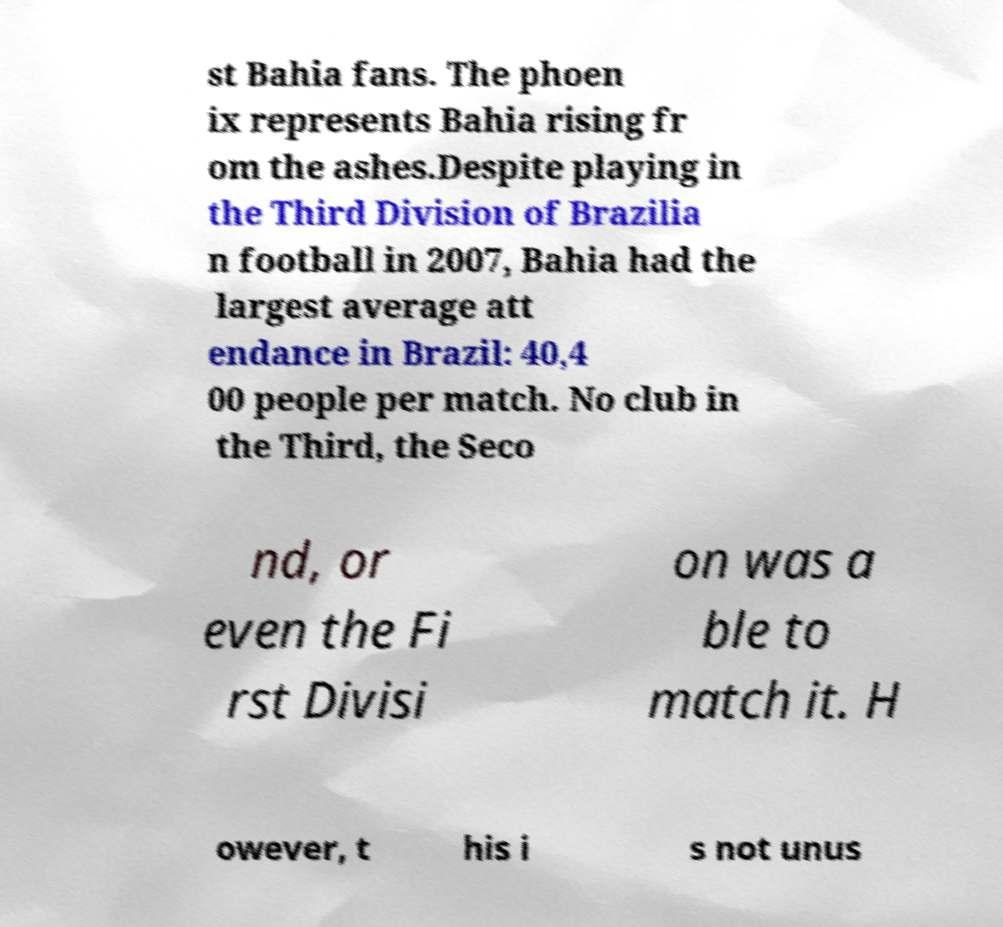For documentation purposes, I need the text within this image transcribed. Could you provide that? st Bahia fans. The phoen ix represents Bahia rising fr om the ashes.Despite playing in the Third Division of Brazilia n football in 2007, Bahia had the largest average att endance in Brazil: 40,4 00 people per match. No club in the Third, the Seco nd, or even the Fi rst Divisi on was a ble to match it. H owever, t his i s not unus 